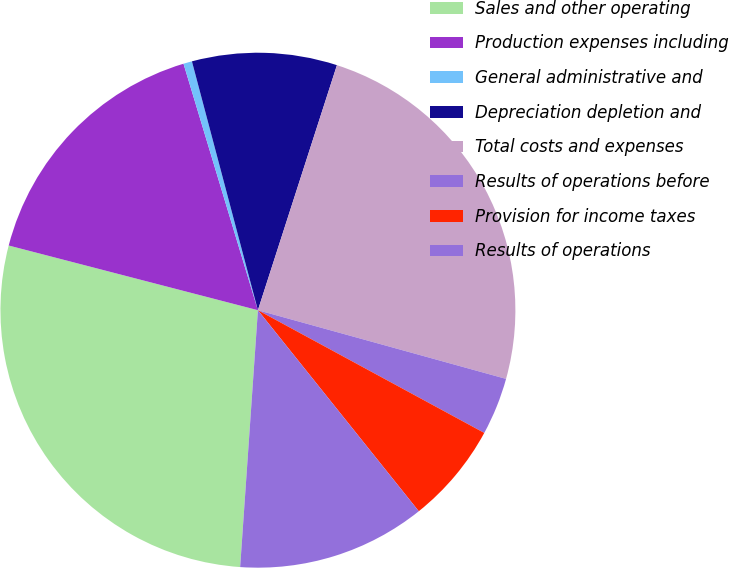Convert chart to OTSL. <chart><loc_0><loc_0><loc_500><loc_500><pie_chart><fcel>Sales and other operating<fcel>Production expenses including<fcel>General administrative and<fcel>Depreciation depletion and<fcel>Total costs and expenses<fcel>Results of operations before<fcel>Provision for income taxes<fcel>Results of operations<nl><fcel>27.94%<fcel>16.29%<fcel>0.54%<fcel>9.09%<fcel>24.33%<fcel>3.61%<fcel>6.35%<fcel>11.84%<nl></chart> 